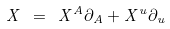Convert formula to latex. <formula><loc_0><loc_0><loc_500><loc_500>X \ = \ X ^ { A } \partial _ { A } + X ^ { u } \partial _ { u }</formula> 